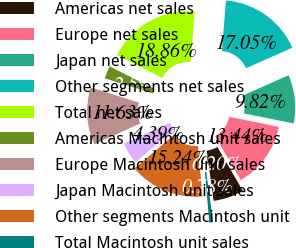<chart> <loc_0><loc_0><loc_500><loc_500><pie_chart><fcel>Americas net sales<fcel>Europe net sales<fcel>Japan net sales<fcel>Other segments net sales<fcel>Total net sales<fcel>Americas Macintosh unit sales<fcel>Europe Macintosh unit sales<fcel>Japan Macintosh unit sales<fcel>Other segments Macintosh unit<fcel>Total Macintosh unit sales<nl><fcel>6.2%<fcel>13.44%<fcel>9.82%<fcel>17.05%<fcel>18.86%<fcel>2.59%<fcel>11.63%<fcel>4.39%<fcel>15.24%<fcel>0.78%<nl></chart> 